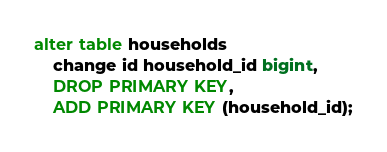Convert code to text. <code><loc_0><loc_0><loc_500><loc_500><_SQL_>alter table households
    change id household_id bigint,
    DROP PRIMARY KEY,
    ADD PRIMARY KEY (household_id);</code> 